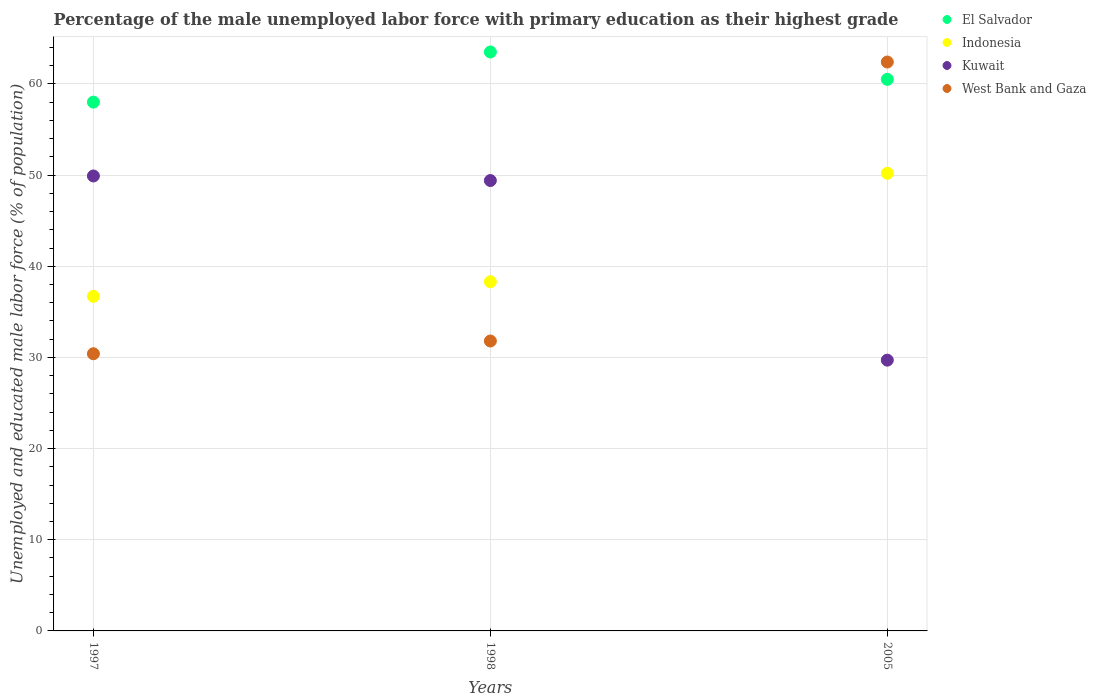How many different coloured dotlines are there?
Provide a succinct answer. 4. Is the number of dotlines equal to the number of legend labels?
Keep it short and to the point. Yes. What is the percentage of the unemployed male labor force with primary education in Kuwait in 1998?
Ensure brevity in your answer.  49.4. Across all years, what is the maximum percentage of the unemployed male labor force with primary education in Indonesia?
Make the answer very short. 50.2. In which year was the percentage of the unemployed male labor force with primary education in Indonesia maximum?
Give a very brief answer. 2005. In which year was the percentage of the unemployed male labor force with primary education in Kuwait minimum?
Your response must be concise. 2005. What is the total percentage of the unemployed male labor force with primary education in El Salvador in the graph?
Make the answer very short. 182. What is the difference between the percentage of the unemployed male labor force with primary education in El Salvador in 1997 and that in 2005?
Your answer should be very brief. -2.5. What is the difference between the percentage of the unemployed male labor force with primary education in El Salvador in 1997 and the percentage of the unemployed male labor force with primary education in Kuwait in 2005?
Provide a short and direct response. 28.3. What is the average percentage of the unemployed male labor force with primary education in Indonesia per year?
Keep it short and to the point. 41.73. In the year 2005, what is the difference between the percentage of the unemployed male labor force with primary education in Kuwait and percentage of the unemployed male labor force with primary education in El Salvador?
Give a very brief answer. -30.8. In how many years, is the percentage of the unemployed male labor force with primary education in West Bank and Gaza greater than 50 %?
Provide a short and direct response. 1. What is the ratio of the percentage of the unemployed male labor force with primary education in West Bank and Gaza in 1998 to that in 2005?
Your answer should be very brief. 0.51. What is the difference between the highest and the second highest percentage of the unemployed male labor force with primary education in West Bank and Gaza?
Offer a very short reply. 30.6. What is the difference between the highest and the lowest percentage of the unemployed male labor force with primary education in Kuwait?
Provide a short and direct response. 20.2. Is the sum of the percentage of the unemployed male labor force with primary education in Kuwait in 1997 and 1998 greater than the maximum percentage of the unemployed male labor force with primary education in Indonesia across all years?
Provide a short and direct response. Yes. Is it the case that in every year, the sum of the percentage of the unemployed male labor force with primary education in Kuwait and percentage of the unemployed male labor force with primary education in Indonesia  is greater than the sum of percentage of the unemployed male labor force with primary education in El Salvador and percentage of the unemployed male labor force with primary education in West Bank and Gaza?
Your response must be concise. No. Is it the case that in every year, the sum of the percentage of the unemployed male labor force with primary education in El Salvador and percentage of the unemployed male labor force with primary education in West Bank and Gaza  is greater than the percentage of the unemployed male labor force with primary education in Kuwait?
Your response must be concise. Yes. Does the percentage of the unemployed male labor force with primary education in El Salvador monotonically increase over the years?
Ensure brevity in your answer.  No. Is the percentage of the unemployed male labor force with primary education in Kuwait strictly greater than the percentage of the unemployed male labor force with primary education in Indonesia over the years?
Your answer should be compact. No. Is the percentage of the unemployed male labor force with primary education in Kuwait strictly less than the percentage of the unemployed male labor force with primary education in El Salvador over the years?
Provide a succinct answer. Yes. How many legend labels are there?
Keep it short and to the point. 4. How are the legend labels stacked?
Keep it short and to the point. Vertical. What is the title of the graph?
Ensure brevity in your answer.  Percentage of the male unemployed labor force with primary education as their highest grade. Does "Marshall Islands" appear as one of the legend labels in the graph?
Offer a very short reply. No. What is the label or title of the Y-axis?
Provide a short and direct response. Unemployed and educated male labor force (% of population). What is the Unemployed and educated male labor force (% of population) of El Salvador in 1997?
Make the answer very short. 58. What is the Unemployed and educated male labor force (% of population) in Indonesia in 1997?
Offer a very short reply. 36.7. What is the Unemployed and educated male labor force (% of population) of Kuwait in 1997?
Your answer should be compact. 49.9. What is the Unemployed and educated male labor force (% of population) in West Bank and Gaza in 1997?
Your answer should be compact. 30.4. What is the Unemployed and educated male labor force (% of population) of El Salvador in 1998?
Keep it short and to the point. 63.5. What is the Unemployed and educated male labor force (% of population) of Indonesia in 1998?
Provide a succinct answer. 38.3. What is the Unemployed and educated male labor force (% of population) of Kuwait in 1998?
Make the answer very short. 49.4. What is the Unemployed and educated male labor force (% of population) in West Bank and Gaza in 1998?
Your answer should be very brief. 31.8. What is the Unemployed and educated male labor force (% of population) of El Salvador in 2005?
Make the answer very short. 60.5. What is the Unemployed and educated male labor force (% of population) in Indonesia in 2005?
Ensure brevity in your answer.  50.2. What is the Unemployed and educated male labor force (% of population) in Kuwait in 2005?
Your answer should be compact. 29.7. What is the Unemployed and educated male labor force (% of population) in West Bank and Gaza in 2005?
Give a very brief answer. 62.4. Across all years, what is the maximum Unemployed and educated male labor force (% of population) in El Salvador?
Make the answer very short. 63.5. Across all years, what is the maximum Unemployed and educated male labor force (% of population) of Indonesia?
Ensure brevity in your answer.  50.2. Across all years, what is the maximum Unemployed and educated male labor force (% of population) of Kuwait?
Give a very brief answer. 49.9. Across all years, what is the maximum Unemployed and educated male labor force (% of population) in West Bank and Gaza?
Ensure brevity in your answer.  62.4. Across all years, what is the minimum Unemployed and educated male labor force (% of population) in Indonesia?
Keep it short and to the point. 36.7. Across all years, what is the minimum Unemployed and educated male labor force (% of population) of Kuwait?
Keep it short and to the point. 29.7. Across all years, what is the minimum Unemployed and educated male labor force (% of population) in West Bank and Gaza?
Your response must be concise. 30.4. What is the total Unemployed and educated male labor force (% of population) in El Salvador in the graph?
Ensure brevity in your answer.  182. What is the total Unemployed and educated male labor force (% of population) in Indonesia in the graph?
Keep it short and to the point. 125.2. What is the total Unemployed and educated male labor force (% of population) in Kuwait in the graph?
Offer a terse response. 129. What is the total Unemployed and educated male labor force (% of population) of West Bank and Gaza in the graph?
Provide a succinct answer. 124.6. What is the difference between the Unemployed and educated male labor force (% of population) of West Bank and Gaza in 1997 and that in 1998?
Give a very brief answer. -1.4. What is the difference between the Unemployed and educated male labor force (% of population) of Indonesia in 1997 and that in 2005?
Offer a very short reply. -13.5. What is the difference between the Unemployed and educated male labor force (% of population) in Kuwait in 1997 and that in 2005?
Provide a succinct answer. 20.2. What is the difference between the Unemployed and educated male labor force (% of population) in West Bank and Gaza in 1997 and that in 2005?
Offer a very short reply. -32. What is the difference between the Unemployed and educated male labor force (% of population) in Kuwait in 1998 and that in 2005?
Your answer should be very brief. 19.7. What is the difference between the Unemployed and educated male labor force (% of population) in West Bank and Gaza in 1998 and that in 2005?
Provide a short and direct response. -30.6. What is the difference between the Unemployed and educated male labor force (% of population) in El Salvador in 1997 and the Unemployed and educated male labor force (% of population) in Kuwait in 1998?
Provide a succinct answer. 8.6. What is the difference between the Unemployed and educated male labor force (% of population) in El Salvador in 1997 and the Unemployed and educated male labor force (% of population) in West Bank and Gaza in 1998?
Your response must be concise. 26.2. What is the difference between the Unemployed and educated male labor force (% of population) of Indonesia in 1997 and the Unemployed and educated male labor force (% of population) of Kuwait in 1998?
Give a very brief answer. -12.7. What is the difference between the Unemployed and educated male labor force (% of population) in Indonesia in 1997 and the Unemployed and educated male labor force (% of population) in West Bank and Gaza in 1998?
Your response must be concise. 4.9. What is the difference between the Unemployed and educated male labor force (% of population) of Kuwait in 1997 and the Unemployed and educated male labor force (% of population) of West Bank and Gaza in 1998?
Offer a terse response. 18.1. What is the difference between the Unemployed and educated male labor force (% of population) in El Salvador in 1997 and the Unemployed and educated male labor force (% of population) in Indonesia in 2005?
Provide a succinct answer. 7.8. What is the difference between the Unemployed and educated male labor force (% of population) in El Salvador in 1997 and the Unemployed and educated male labor force (% of population) in Kuwait in 2005?
Your answer should be compact. 28.3. What is the difference between the Unemployed and educated male labor force (% of population) in Indonesia in 1997 and the Unemployed and educated male labor force (% of population) in Kuwait in 2005?
Your answer should be compact. 7. What is the difference between the Unemployed and educated male labor force (% of population) in Indonesia in 1997 and the Unemployed and educated male labor force (% of population) in West Bank and Gaza in 2005?
Your answer should be very brief. -25.7. What is the difference between the Unemployed and educated male labor force (% of population) in Kuwait in 1997 and the Unemployed and educated male labor force (% of population) in West Bank and Gaza in 2005?
Your answer should be very brief. -12.5. What is the difference between the Unemployed and educated male labor force (% of population) of El Salvador in 1998 and the Unemployed and educated male labor force (% of population) of Kuwait in 2005?
Make the answer very short. 33.8. What is the difference between the Unemployed and educated male labor force (% of population) of Indonesia in 1998 and the Unemployed and educated male labor force (% of population) of West Bank and Gaza in 2005?
Ensure brevity in your answer.  -24.1. What is the difference between the Unemployed and educated male labor force (% of population) in Kuwait in 1998 and the Unemployed and educated male labor force (% of population) in West Bank and Gaza in 2005?
Ensure brevity in your answer.  -13. What is the average Unemployed and educated male labor force (% of population) in El Salvador per year?
Give a very brief answer. 60.67. What is the average Unemployed and educated male labor force (% of population) in Indonesia per year?
Your answer should be very brief. 41.73. What is the average Unemployed and educated male labor force (% of population) of Kuwait per year?
Ensure brevity in your answer.  43. What is the average Unemployed and educated male labor force (% of population) of West Bank and Gaza per year?
Offer a terse response. 41.53. In the year 1997, what is the difference between the Unemployed and educated male labor force (% of population) in El Salvador and Unemployed and educated male labor force (% of population) in Indonesia?
Your answer should be compact. 21.3. In the year 1997, what is the difference between the Unemployed and educated male labor force (% of population) in El Salvador and Unemployed and educated male labor force (% of population) in West Bank and Gaza?
Provide a short and direct response. 27.6. In the year 1997, what is the difference between the Unemployed and educated male labor force (% of population) in Kuwait and Unemployed and educated male labor force (% of population) in West Bank and Gaza?
Ensure brevity in your answer.  19.5. In the year 1998, what is the difference between the Unemployed and educated male labor force (% of population) in El Salvador and Unemployed and educated male labor force (% of population) in Indonesia?
Offer a terse response. 25.2. In the year 1998, what is the difference between the Unemployed and educated male labor force (% of population) of El Salvador and Unemployed and educated male labor force (% of population) of Kuwait?
Your response must be concise. 14.1. In the year 1998, what is the difference between the Unemployed and educated male labor force (% of population) in El Salvador and Unemployed and educated male labor force (% of population) in West Bank and Gaza?
Provide a succinct answer. 31.7. In the year 1998, what is the difference between the Unemployed and educated male labor force (% of population) of Indonesia and Unemployed and educated male labor force (% of population) of Kuwait?
Ensure brevity in your answer.  -11.1. In the year 2005, what is the difference between the Unemployed and educated male labor force (% of population) in El Salvador and Unemployed and educated male labor force (% of population) in Indonesia?
Your answer should be very brief. 10.3. In the year 2005, what is the difference between the Unemployed and educated male labor force (% of population) of El Salvador and Unemployed and educated male labor force (% of population) of Kuwait?
Provide a succinct answer. 30.8. In the year 2005, what is the difference between the Unemployed and educated male labor force (% of population) in Indonesia and Unemployed and educated male labor force (% of population) in Kuwait?
Provide a short and direct response. 20.5. In the year 2005, what is the difference between the Unemployed and educated male labor force (% of population) of Indonesia and Unemployed and educated male labor force (% of population) of West Bank and Gaza?
Keep it short and to the point. -12.2. In the year 2005, what is the difference between the Unemployed and educated male labor force (% of population) of Kuwait and Unemployed and educated male labor force (% of population) of West Bank and Gaza?
Make the answer very short. -32.7. What is the ratio of the Unemployed and educated male labor force (% of population) in El Salvador in 1997 to that in 1998?
Your answer should be compact. 0.91. What is the ratio of the Unemployed and educated male labor force (% of population) in Indonesia in 1997 to that in 1998?
Provide a succinct answer. 0.96. What is the ratio of the Unemployed and educated male labor force (% of population) in Kuwait in 1997 to that in 1998?
Offer a very short reply. 1.01. What is the ratio of the Unemployed and educated male labor force (% of population) of West Bank and Gaza in 1997 to that in 1998?
Your answer should be compact. 0.96. What is the ratio of the Unemployed and educated male labor force (% of population) of El Salvador in 1997 to that in 2005?
Make the answer very short. 0.96. What is the ratio of the Unemployed and educated male labor force (% of population) of Indonesia in 1997 to that in 2005?
Give a very brief answer. 0.73. What is the ratio of the Unemployed and educated male labor force (% of population) in Kuwait in 1997 to that in 2005?
Your response must be concise. 1.68. What is the ratio of the Unemployed and educated male labor force (% of population) of West Bank and Gaza in 1997 to that in 2005?
Your answer should be very brief. 0.49. What is the ratio of the Unemployed and educated male labor force (% of population) in El Salvador in 1998 to that in 2005?
Your response must be concise. 1.05. What is the ratio of the Unemployed and educated male labor force (% of population) in Indonesia in 1998 to that in 2005?
Make the answer very short. 0.76. What is the ratio of the Unemployed and educated male labor force (% of population) of Kuwait in 1998 to that in 2005?
Offer a very short reply. 1.66. What is the ratio of the Unemployed and educated male labor force (% of population) of West Bank and Gaza in 1998 to that in 2005?
Offer a terse response. 0.51. What is the difference between the highest and the second highest Unemployed and educated male labor force (% of population) in Kuwait?
Ensure brevity in your answer.  0.5. What is the difference between the highest and the second highest Unemployed and educated male labor force (% of population) of West Bank and Gaza?
Offer a terse response. 30.6. What is the difference between the highest and the lowest Unemployed and educated male labor force (% of population) of Indonesia?
Your answer should be very brief. 13.5. What is the difference between the highest and the lowest Unemployed and educated male labor force (% of population) of Kuwait?
Provide a short and direct response. 20.2. What is the difference between the highest and the lowest Unemployed and educated male labor force (% of population) of West Bank and Gaza?
Provide a succinct answer. 32. 